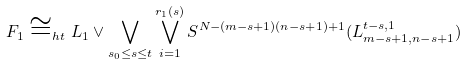<formula> <loc_0><loc_0><loc_500><loc_500>F _ { 1 } \cong _ { h t } L _ { 1 } \vee \bigvee _ { s _ { 0 } \leq s \leq t } \bigvee _ { i = 1 } ^ { r _ { 1 } ( s ) } S ^ { N - ( m - s + 1 ) ( n - s + 1 ) + 1 } ( L _ { m - s + 1 , n - s + 1 } ^ { t - s , 1 } )</formula> 